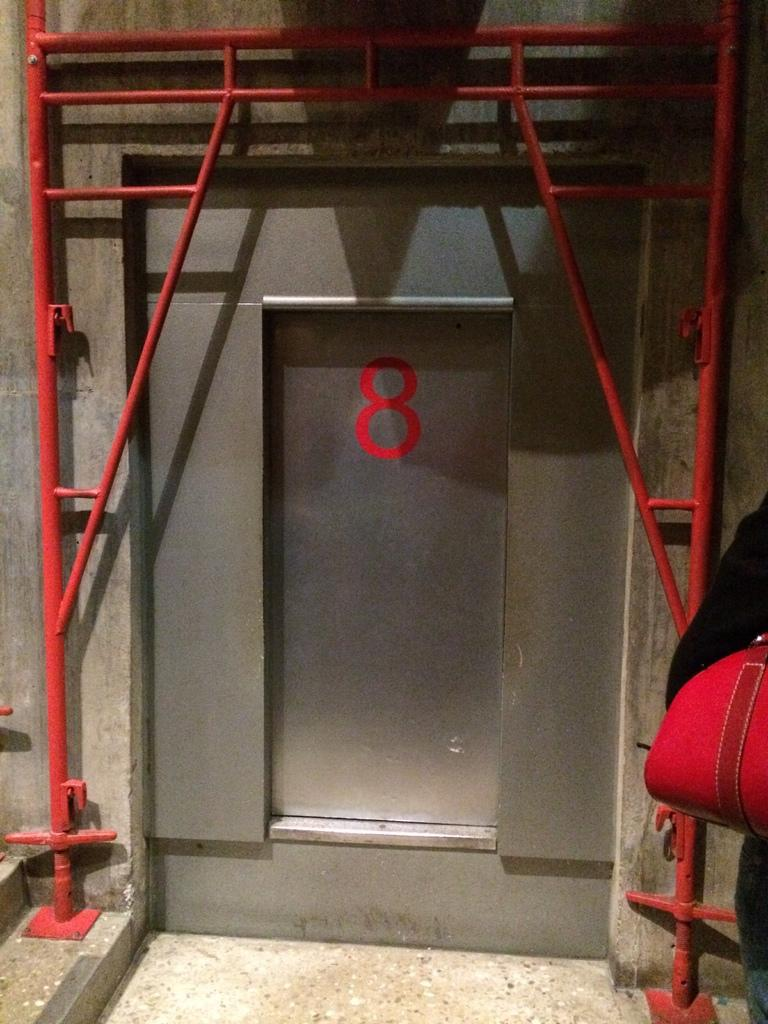What is the main subject in the foreground of the image? There is a person in the foreground of the image. What is the person wearing that is red in color? The person is wearing a red color bag. What type of door can be seen in the middle of the image? There is a steel door in the middle of the image. What are the red rod-like structures in the middle of the image? The red rod-like structures in the middle of the image are not specified, but they are red and appear to be part of the overall scene. What organization is responsible for maintaining the person's knee in the image? There is no mention of a knee or an organization responsible for maintaining it in the image. 